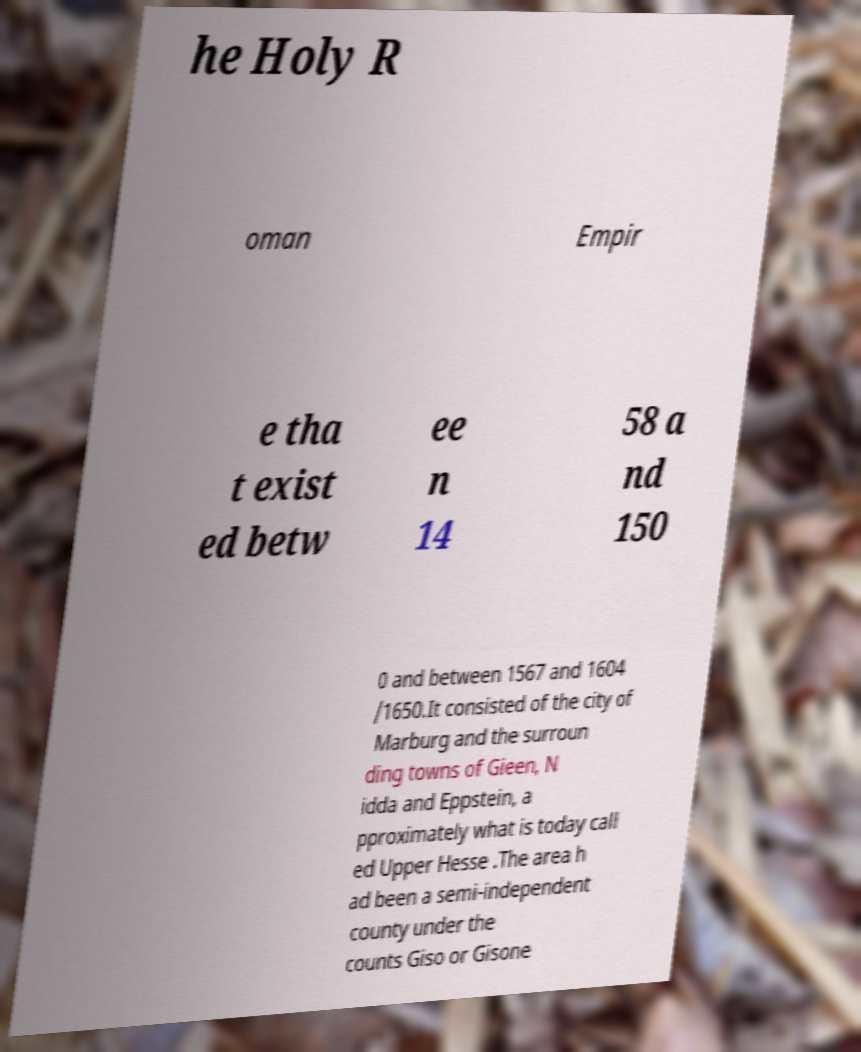Please read and relay the text visible in this image. What does it say? he Holy R oman Empir e tha t exist ed betw ee n 14 58 a nd 150 0 and between 1567 and 1604 /1650.It consisted of the city of Marburg and the surroun ding towns of Gieen, N idda and Eppstein, a pproximately what is today call ed Upper Hesse .The area h ad been a semi-independent county under the counts Giso or Gisone 